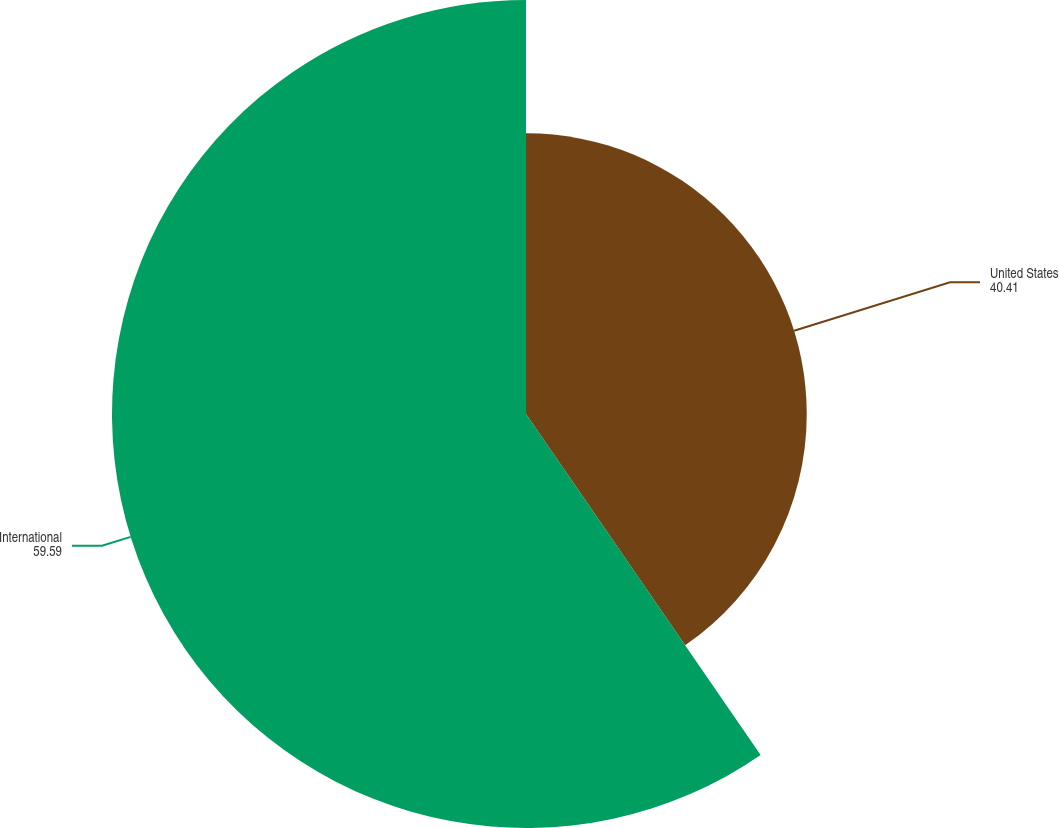<chart> <loc_0><loc_0><loc_500><loc_500><pie_chart><fcel>United States<fcel>International<nl><fcel>40.41%<fcel>59.59%<nl></chart> 